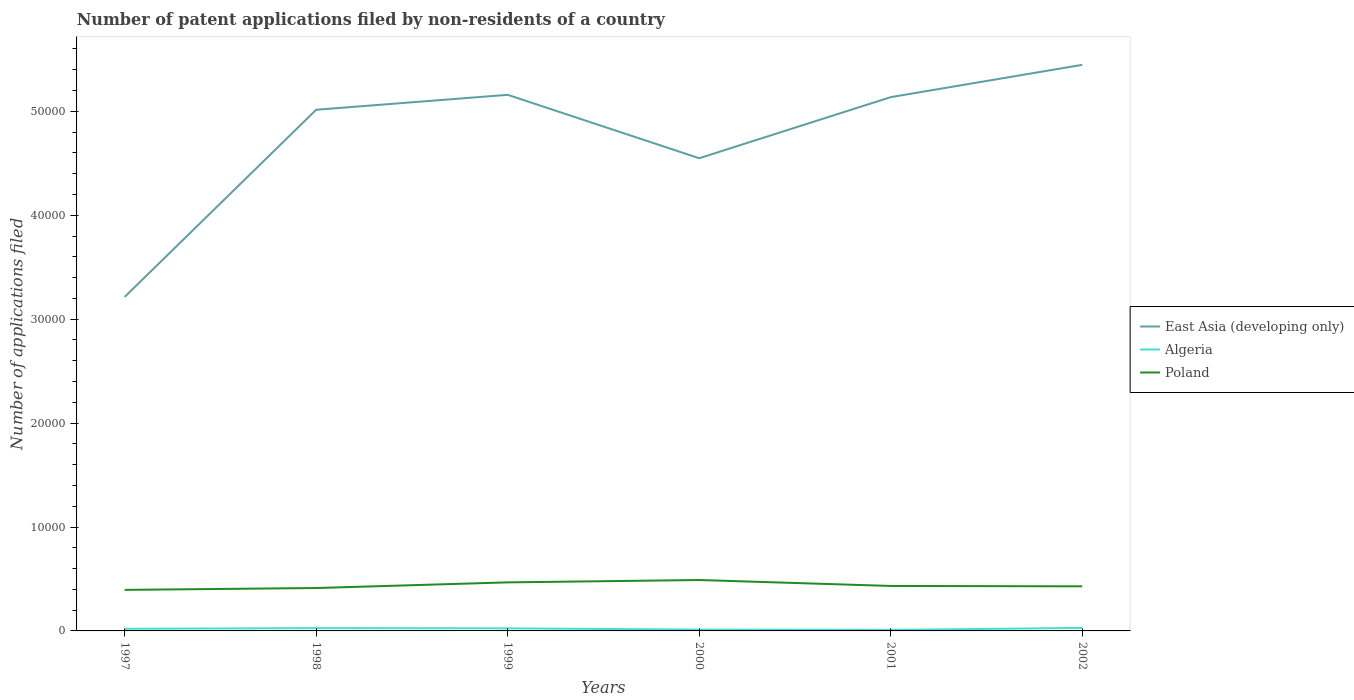Across all years, what is the maximum number of applications filed in East Asia (developing only)?
Ensure brevity in your answer.  3.21e+04. In which year was the number of applications filed in Poland maximum?
Offer a very short reply. 1997. What is the total number of applications filed in East Asia (developing only) in the graph?
Provide a succinct answer. -1.92e+04. What is the difference between the highest and the second highest number of applications filed in Poland?
Offer a very short reply. 949. Is the number of applications filed in Algeria strictly greater than the number of applications filed in East Asia (developing only) over the years?
Make the answer very short. Yes. How many lines are there?
Give a very brief answer. 3. What is the difference between two consecutive major ticks on the Y-axis?
Offer a very short reply. 10000. Does the graph contain any zero values?
Your answer should be very brief. No. Does the graph contain grids?
Ensure brevity in your answer.  No. How many legend labels are there?
Your answer should be compact. 3. How are the legend labels stacked?
Make the answer very short. Vertical. What is the title of the graph?
Offer a terse response. Number of patent applications filed by non-residents of a country. What is the label or title of the Y-axis?
Keep it short and to the point. Number of applications filed. What is the Number of applications filed of East Asia (developing only) in 1997?
Provide a succinct answer. 3.21e+04. What is the Number of applications filed of Algeria in 1997?
Offer a terse response. 207. What is the Number of applications filed in Poland in 1997?
Your answer should be very brief. 3950. What is the Number of applications filed of East Asia (developing only) in 1998?
Your answer should be compact. 5.02e+04. What is the Number of applications filed in Algeria in 1998?
Offer a terse response. 267. What is the Number of applications filed in Poland in 1998?
Give a very brief answer. 4128. What is the Number of applications filed of East Asia (developing only) in 1999?
Provide a short and direct response. 5.16e+04. What is the Number of applications filed of Algeria in 1999?
Offer a very short reply. 248. What is the Number of applications filed of Poland in 1999?
Offer a very short reply. 4671. What is the Number of applications filed in East Asia (developing only) in 2000?
Keep it short and to the point. 4.55e+04. What is the Number of applications filed in Algeria in 2000?
Your answer should be compact. 127. What is the Number of applications filed in Poland in 2000?
Make the answer very short. 4899. What is the Number of applications filed in East Asia (developing only) in 2001?
Give a very brief answer. 5.14e+04. What is the Number of applications filed of Algeria in 2001?
Ensure brevity in your answer.  94. What is the Number of applications filed of Poland in 2001?
Make the answer very short. 4328. What is the Number of applications filed in East Asia (developing only) in 2002?
Ensure brevity in your answer.  5.45e+04. What is the Number of applications filed in Algeria in 2002?
Provide a succinct answer. 291. What is the Number of applications filed of Poland in 2002?
Your response must be concise. 4292. Across all years, what is the maximum Number of applications filed in East Asia (developing only)?
Your answer should be compact. 5.45e+04. Across all years, what is the maximum Number of applications filed in Algeria?
Make the answer very short. 291. Across all years, what is the maximum Number of applications filed in Poland?
Your answer should be very brief. 4899. Across all years, what is the minimum Number of applications filed in East Asia (developing only)?
Give a very brief answer. 3.21e+04. Across all years, what is the minimum Number of applications filed in Algeria?
Give a very brief answer. 94. Across all years, what is the minimum Number of applications filed of Poland?
Provide a short and direct response. 3950. What is the total Number of applications filed of East Asia (developing only) in the graph?
Keep it short and to the point. 2.85e+05. What is the total Number of applications filed of Algeria in the graph?
Ensure brevity in your answer.  1234. What is the total Number of applications filed of Poland in the graph?
Make the answer very short. 2.63e+04. What is the difference between the Number of applications filed of East Asia (developing only) in 1997 and that in 1998?
Give a very brief answer. -1.80e+04. What is the difference between the Number of applications filed in Algeria in 1997 and that in 1998?
Your answer should be very brief. -60. What is the difference between the Number of applications filed in Poland in 1997 and that in 1998?
Your answer should be compact. -178. What is the difference between the Number of applications filed in East Asia (developing only) in 1997 and that in 1999?
Provide a short and direct response. -1.95e+04. What is the difference between the Number of applications filed of Algeria in 1997 and that in 1999?
Offer a terse response. -41. What is the difference between the Number of applications filed of Poland in 1997 and that in 1999?
Give a very brief answer. -721. What is the difference between the Number of applications filed in East Asia (developing only) in 1997 and that in 2000?
Your answer should be compact. -1.34e+04. What is the difference between the Number of applications filed in Algeria in 1997 and that in 2000?
Ensure brevity in your answer.  80. What is the difference between the Number of applications filed of Poland in 1997 and that in 2000?
Your answer should be very brief. -949. What is the difference between the Number of applications filed of East Asia (developing only) in 1997 and that in 2001?
Keep it short and to the point. -1.92e+04. What is the difference between the Number of applications filed of Algeria in 1997 and that in 2001?
Provide a short and direct response. 113. What is the difference between the Number of applications filed of Poland in 1997 and that in 2001?
Keep it short and to the point. -378. What is the difference between the Number of applications filed of East Asia (developing only) in 1997 and that in 2002?
Keep it short and to the point. -2.23e+04. What is the difference between the Number of applications filed in Algeria in 1997 and that in 2002?
Give a very brief answer. -84. What is the difference between the Number of applications filed in Poland in 1997 and that in 2002?
Offer a very short reply. -342. What is the difference between the Number of applications filed of East Asia (developing only) in 1998 and that in 1999?
Offer a very short reply. -1438. What is the difference between the Number of applications filed of Algeria in 1998 and that in 1999?
Keep it short and to the point. 19. What is the difference between the Number of applications filed in Poland in 1998 and that in 1999?
Your answer should be very brief. -543. What is the difference between the Number of applications filed in East Asia (developing only) in 1998 and that in 2000?
Make the answer very short. 4663. What is the difference between the Number of applications filed in Algeria in 1998 and that in 2000?
Provide a short and direct response. 140. What is the difference between the Number of applications filed in Poland in 1998 and that in 2000?
Your response must be concise. -771. What is the difference between the Number of applications filed in East Asia (developing only) in 1998 and that in 2001?
Keep it short and to the point. -1215. What is the difference between the Number of applications filed in Algeria in 1998 and that in 2001?
Your answer should be compact. 173. What is the difference between the Number of applications filed in Poland in 1998 and that in 2001?
Provide a succinct answer. -200. What is the difference between the Number of applications filed in East Asia (developing only) in 1998 and that in 2002?
Keep it short and to the point. -4324. What is the difference between the Number of applications filed of Algeria in 1998 and that in 2002?
Ensure brevity in your answer.  -24. What is the difference between the Number of applications filed of Poland in 1998 and that in 2002?
Your answer should be very brief. -164. What is the difference between the Number of applications filed in East Asia (developing only) in 1999 and that in 2000?
Give a very brief answer. 6101. What is the difference between the Number of applications filed of Algeria in 1999 and that in 2000?
Provide a succinct answer. 121. What is the difference between the Number of applications filed in Poland in 1999 and that in 2000?
Offer a terse response. -228. What is the difference between the Number of applications filed in East Asia (developing only) in 1999 and that in 2001?
Keep it short and to the point. 223. What is the difference between the Number of applications filed in Algeria in 1999 and that in 2001?
Provide a short and direct response. 154. What is the difference between the Number of applications filed of Poland in 1999 and that in 2001?
Ensure brevity in your answer.  343. What is the difference between the Number of applications filed of East Asia (developing only) in 1999 and that in 2002?
Make the answer very short. -2886. What is the difference between the Number of applications filed in Algeria in 1999 and that in 2002?
Make the answer very short. -43. What is the difference between the Number of applications filed in Poland in 1999 and that in 2002?
Your answer should be compact. 379. What is the difference between the Number of applications filed in East Asia (developing only) in 2000 and that in 2001?
Make the answer very short. -5878. What is the difference between the Number of applications filed of Poland in 2000 and that in 2001?
Offer a terse response. 571. What is the difference between the Number of applications filed of East Asia (developing only) in 2000 and that in 2002?
Make the answer very short. -8987. What is the difference between the Number of applications filed in Algeria in 2000 and that in 2002?
Make the answer very short. -164. What is the difference between the Number of applications filed of Poland in 2000 and that in 2002?
Provide a short and direct response. 607. What is the difference between the Number of applications filed of East Asia (developing only) in 2001 and that in 2002?
Keep it short and to the point. -3109. What is the difference between the Number of applications filed of Algeria in 2001 and that in 2002?
Your response must be concise. -197. What is the difference between the Number of applications filed of Poland in 2001 and that in 2002?
Your response must be concise. 36. What is the difference between the Number of applications filed of East Asia (developing only) in 1997 and the Number of applications filed of Algeria in 1998?
Keep it short and to the point. 3.19e+04. What is the difference between the Number of applications filed of East Asia (developing only) in 1997 and the Number of applications filed of Poland in 1998?
Provide a short and direct response. 2.80e+04. What is the difference between the Number of applications filed in Algeria in 1997 and the Number of applications filed in Poland in 1998?
Your answer should be very brief. -3921. What is the difference between the Number of applications filed in East Asia (developing only) in 1997 and the Number of applications filed in Algeria in 1999?
Your response must be concise. 3.19e+04. What is the difference between the Number of applications filed in East Asia (developing only) in 1997 and the Number of applications filed in Poland in 1999?
Your response must be concise. 2.75e+04. What is the difference between the Number of applications filed in Algeria in 1997 and the Number of applications filed in Poland in 1999?
Provide a short and direct response. -4464. What is the difference between the Number of applications filed of East Asia (developing only) in 1997 and the Number of applications filed of Algeria in 2000?
Your answer should be very brief. 3.20e+04. What is the difference between the Number of applications filed in East Asia (developing only) in 1997 and the Number of applications filed in Poland in 2000?
Give a very brief answer. 2.72e+04. What is the difference between the Number of applications filed in Algeria in 1997 and the Number of applications filed in Poland in 2000?
Keep it short and to the point. -4692. What is the difference between the Number of applications filed of East Asia (developing only) in 1997 and the Number of applications filed of Algeria in 2001?
Your answer should be compact. 3.20e+04. What is the difference between the Number of applications filed in East Asia (developing only) in 1997 and the Number of applications filed in Poland in 2001?
Your response must be concise. 2.78e+04. What is the difference between the Number of applications filed in Algeria in 1997 and the Number of applications filed in Poland in 2001?
Your answer should be compact. -4121. What is the difference between the Number of applications filed in East Asia (developing only) in 1997 and the Number of applications filed in Algeria in 2002?
Ensure brevity in your answer.  3.18e+04. What is the difference between the Number of applications filed in East Asia (developing only) in 1997 and the Number of applications filed in Poland in 2002?
Your answer should be compact. 2.78e+04. What is the difference between the Number of applications filed in Algeria in 1997 and the Number of applications filed in Poland in 2002?
Your answer should be compact. -4085. What is the difference between the Number of applications filed of East Asia (developing only) in 1998 and the Number of applications filed of Algeria in 1999?
Provide a succinct answer. 4.99e+04. What is the difference between the Number of applications filed in East Asia (developing only) in 1998 and the Number of applications filed in Poland in 1999?
Provide a succinct answer. 4.55e+04. What is the difference between the Number of applications filed of Algeria in 1998 and the Number of applications filed of Poland in 1999?
Offer a terse response. -4404. What is the difference between the Number of applications filed of East Asia (developing only) in 1998 and the Number of applications filed of Algeria in 2000?
Your response must be concise. 5.00e+04. What is the difference between the Number of applications filed of East Asia (developing only) in 1998 and the Number of applications filed of Poland in 2000?
Provide a short and direct response. 4.53e+04. What is the difference between the Number of applications filed in Algeria in 1998 and the Number of applications filed in Poland in 2000?
Offer a very short reply. -4632. What is the difference between the Number of applications filed in East Asia (developing only) in 1998 and the Number of applications filed in Algeria in 2001?
Keep it short and to the point. 5.01e+04. What is the difference between the Number of applications filed of East Asia (developing only) in 1998 and the Number of applications filed of Poland in 2001?
Your answer should be very brief. 4.58e+04. What is the difference between the Number of applications filed of Algeria in 1998 and the Number of applications filed of Poland in 2001?
Offer a terse response. -4061. What is the difference between the Number of applications filed in East Asia (developing only) in 1998 and the Number of applications filed in Algeria in 2002?
Provide a short and direct response. 4.99e+04. What is the difference between the Number of applications filed in East Asia (developing only) in 1998 and the Number of applications filed in Poland in 2002?
Ensure brevity in your answer.  4.59e+04. What is the difference between the Number of applications filed in Algeria in 1998 and the Number of applications filed in Poland in 2002?
Give a very brief answer. -4025. What is the difference between the Number of applications filed in East Asia (developing only) in 1999 and the Number of applications filed in Algeria in 2000?
Your answer should be compact. 5.15e+04. What is the difference between the Number of applications filed in East Asia (developing only) in 1999 and the Number of applications filed in Poland in 2000?
Your answer should be compact. 4.67e+04. What is the difference between the Number of applications filed in Algeria in 1999 and the Number of applications filed in Poland in 2000?
Your response must be concise. -4651. What is the difference between the Number of applications filed of East Asia (developing only) in 1999 and the Number of applications filed of Algeria in 2001?
Offer a very short reply. 5.15e+04. What is the difference between the Number of applications filed of East Asia (developing only) in 1999 and the Number of applications filed of Poland in 2001?
Your response must be concise. 4.73e+04. What is the difference between the Number of applications filed in Algeria in 1999 and the Number of applications filed in Poland in 2001?
Keep it short and to the point. -4080. What is the difference between the Number of applications filed of East Asia (developing only) in 1999 and the Number of applications filed of Algeria in 2002?
Your answer should be compact. 5.13e+04. What is the difference between the Number of applications filed of East Asia (developing only) in 1999 and the Number of applications filed of Poland in 2002?
Provide a succinct answer. 4.73e+04. What is the difference between the Number of applications filed in Algeria in 1999 and the Number of applications filed in Poland in 2002?
Offer a terse response. -4044. What is the difference between the Number of applications filed in East Asia (developing only) in 2000 and the Number of applications filed in Algeria in 2001?
Your response must be concise. 4.54e+04. What is the difference between the Number of applications filed in East Asia (developing only) in 2000 and the Number of applications filed in Poland in 2001?
Give a very brief answer. 4.12e+04. What is the difference between the Number of applications filed in Algeria in 2000 and the Number of applications filed in Poland in 2001?
Give a very brief answer. -4201. What is the difference between the Number of applications filed of East Asia (developing only) in 2000 and the Number of applications filed of Algeria in 2002?
Offer a terse response. 4.52e+04. What is the difference between the Number of applications filed in East Asia (developing only) in 2000 and the Number of applications filed in Poland in 2002?
Make the answer very short. 4.12e+04. What is the difference between the Number of applications filed in Algeria in 2000 and the Number of applications filed in Poland in 2002?
Give a very brief answer. -4165. What is the difference between the Number of applications filed of East Asia (developing only) in 2001 and the Number of applications filed of Algeria in 2002?
Offer a terse response. 5.11e+04. What is the difference between the Number of applications filed of East Asia (developing only) in 2001 and the Number of applications filed of Poland in 2002?
Offer a terse response. 4.71e+04. What is the difference between the Number of applications filed of Algeria in 2001 and the Number of applications filed of Poland in 2002?
Offer a terse response. -4198. What is the average Number of applications filed of East Asia (developing only) per year?
Your answer should be very brief. 4.75e+04. What is the average Number of applications filed in Algeria per year?
Your response must be concise. 205.67. What is the average Number of applications filed of Poland per year?
Your answer should be compact. 4378. In the year 1997, what is the difference between the Number of applications filed of East Asia (developing only) and Number of applications filed of Algeria?
Your answer should be very brief. 3.19e+04. In the year 1997, what is the difference between the Number of applications filed in East Asia (developing only) and Number of applications filed in Poland?
Keep it short and to the point. 2.82e+04. In the year 1997, what is the difference between the Number of applications filed in Algeria and Number of applications filed in Poland?
Provide a succinct answer. -3743. In the year 1998, what is the difference between the Number of applications filed in East Asia (developing only) and Number of applications filed in Algeria?
Offer a terse response. 4.99e+04. In the year 1998, what is the difference between the Number of applications filed of East Asia (developing only) and Number of applications filed of Poland?
Your response must be concise. 4.60e+04. In the year 1998, what is the difference between the Number of applications filed of Algeria and Number of applications filed of Poland?
Your answer should be very brief. -3861. In the year 1999, what is the difference between the Number of applications filed of East Asia (developing only) and Number of applications filed of Algeria?
Keep it short and to the point. 5.13e+04. In the year 1999, what is the difference between the Number of applications filed in East Asia (developing only) and Number of applications filed in Poland?
Ensure brevity in your answer.  4.69e+04. In the year 1999, what is the difference between the Number of applications filed of Algeria and Number of applications filed of Poland?
Give a very brief answer. -4423. In the year 2000, what is the difference between the Number of applications filed of East Asia (developing only) and Number of applications filed of Algeria?
Make the answer very short. 4.54e+04. In the year 2000, what is the difference between the Number of applications filed of East Asia (developing only) and Number of applications filed of Poland?
Your answer should be very brief. 4.06e+04. In the year 2000, what is the difference between the Number of applications filed of Algeria and Number of applications filed of Poland?
Give a very brief answer. -4772. In the year 2001, what is the difference between the Number of applications filed in East Asia (developing only) and Number of applications filed in Algeria?
Keep it short and to the point. 5.13e+04. In the year 2001, what is the difference between the Number of applications filed of East Asia (developing only) and Number of applications filed of Poland?
Your answer should be compact. 4.70e+04. In the year 2001, what is the difference between the Number of applications filed of Algeria and Number of applications filed of Poland?
Offer a terse response. -4234. In the year 2002, what is the difference between the Number of applications filed in East Asia (developing only) and Number of applications filed in Algeria?
Offer a very short reply. 5.42e+04. In the year 2002, what is the difference between the Number of applications filed in East Asia (developing only) and Number of applications filed in Poland?
Provide a short and direct response. 5.02e+04. In the year 2002, what is the difference between the Number of applications filed in Algeria and Number of applications filed in Poland?
Give a very brief answer. -4001. What is the ratio of the Number of applications filed in East Asia (developing only) in 1997 to that in 1998?
Ensure brevity in your answer.  0.64. What is the ratio of the Number of applications filed of Algeria in 1997 to that in 1998?
Your answer should be very brief. 0.78. What is the ratio of the Number of applications filed of Poland in 1997 to that in 1998?
Make the answer very short. 0.96. What is the ratio of the Number of applications filed of East Asia (developing only) in 1997 to that in 1999?
Your answer should be very brief. 0.62. What is the ratio of the Number of applications filed of Algeria in 1997 to that in 1999?
Provide a short and direct response. 0.83. What is the ratio of the Number of applications filed of Poland in 1997 to that in 1999?
Provide a succinct answer. 0.85. What is the ratio of the Number of applications filed of East Asia (developing only) in 1997 to that in 2000?
Your response must be concise. 0.71. What is the ratio of the Number of applications filed of Algeria in 1997 to that in 2000?
Ensure brevity in your answer.  1.63. What is the ratio of the Number of applications filed in Poland in 1997 to that in 2000?
Ensure brevity in your answer.  0.81. What is the ratio of the Number of applications filed in East Asia (developing only) in 1997 to that in 2001?
Make the answer very short. 0.63. What is the ratio of the Number of applications filed in Algeria in 1997 to that in 2001?
Make the answer very short. 2.2. What is the ratio of the Number of applications filed in Poland in 1997 to that in 2001?
Provide a short and direct response. 0.91. What is the ratio of the Number of applications filed of East Asia (developing only) in 1997 to that in 2002?
Keep it short and to the point. 0.59. What is the ratio of the Number of applications filed in Algeria in 1997 to that in 2002?
Make the answer very short. 0.71. What is the ratio of the Number of applications filed in Poland in 1997 to that in 2002?
Ensure brevity in your answer.  0.92. What is the ratio of the Number of applications filed in East Asia (developing only) in 1998 to that in 1999?
Provide a succinct answer. 0.97. What is the ratio of the Number of applications filed in Algeria in 1998 to that in 1999?
Provide a succinct answer. 1.08. What is the ratio of the Number of applications filed of Poland in 1998 to that in 1999?
Provide a succinct answer. 0.88. What is the ratio of the Number of applications filed in East Asia (developing only) in 1998 to that in 2000?
Ensure brevity in your answer.  1.1. What is the ratio of the Number of applications filed in Algeria in 1998 to that in 2000?
Offer a very short reply. 2.1. What is the ratio of the Number of applications filed in Poland in 1998 to that in 2000?
Make the answer very short. 0.84. What is the ratio of the Number of applications filed of East Asia (developing only) in 1998 to that in 2001?
Make the answer very short. 0.98. What is the ratio of the Number of applications filed in Algeria in 1998 to that in 2001?
Give a very brief answer. 2.84. What is the ratio of the Number of applications filed of Poland in 1998 to that in 2001?
Give a very brief answer. 0.95. What is the ratio of the Number of applications filed of East Asia (developing only) in 1998 to that in 2002?
Offer a very short reply. 0.92. What is the ratio of the Number of applications filed in Algeria in 1998 to that in 2002?
Keep it short and to the point. 0.92. What is the ratio of the Number of applications filed of Poland in 1998 to that in 2002?
Your response must be concise. 0.96. What is the ratio of the Number of applications filed in East Asia (developing only) in 1999 to that in 2000?
Your answer should be very brief. 1.13. What is the ratio of the Number of applications filed in Algeria in 1999 to that in 2000?
Provide a succinct answer. 1.95. What is the ratio of the Number of applications filed in Poland in 1999 to that in 2000?
Provide a succinct answer. 0.95. What is the ratio of the Number of applications filed of Algeria in 1999 to that in 2001?
Make the answer very short. 2.64. What is the ratio of the Number of applications filed in Poland in 1999 to that in 2001?
Your response must be concise. 1.08. What is the ratio of the Number of applications filed of East Asia (developing only) in 1999 to that in 2002?
Keep it short and to the point. 0.95. What is the ratio of the Number of applications filed in Algeria in 1999 to that in 2002?
Offer a terse response. 0.85. What is the ratio of the Number of applications filed of Poland in 1999 to that in 2002?
Ensure brevity in your answer.  1.09. What is the ratio of the Number of applications filed in East Asia (developing only) in 2000 to that in 2001?
Your response must be concise. 0.89. What is the ratio of the Number of applications filed of Algeria in 2000 to that in 2001?
Your answer should be very brief. 1.35. What is the ratio of the Number of applications filed in Poland in 2000 to that in 2001?
Provide a short and direct response. 1.13. What is the ratio of the Number of applications filed in East Asia (developing only) in 2000 to that in 2002?
Your answer should be very brief. 0.83. What is the ratio of the Number of applications filed of Algeria in 2000 to that in 2002?
Your response must be concise. 0.44. What is the ratio of the Number of applications filed in Poland in 2000 to that in 2002?
Offer a terse response. 1.14. What is the ratio of the Number of applications filed of East Asia (developing only) in 2001 to that in 2002?
Ensure brevity in your answer.  0.94. What is the ratio of the Number of applications filed of Algeria in 2001 to that in 2002?
Give a very brief answer. 0.32. What is the ratio of the Number of applications filed of Poland in 2001 to that in 2002?
Your answer should be compact. 1.01. What is the difference between the highest and the second highest Number of applications filed in East Asia (developing only)?
Provide a short and direct response. 2886. What is the difference between the highest and the second highest Number of applications filed in Algeria?
Your answer should be compact. 24. What is the difference between the highest and the second highest Number of applications filed of Poland?
Provide a short and direct response. 228. What is the difference between the highest and the lowest Number of applications filed of East Asia (developing only)?
Provide a short and direct response. 2.23e+04. What is the difference between the highest and the lowest Number of applications filed in Algeria?
Your response must be concise. 197. What is the difference between the highest and the lowest Number of applications filed of Poland?
Your answer should be compact. 949. 